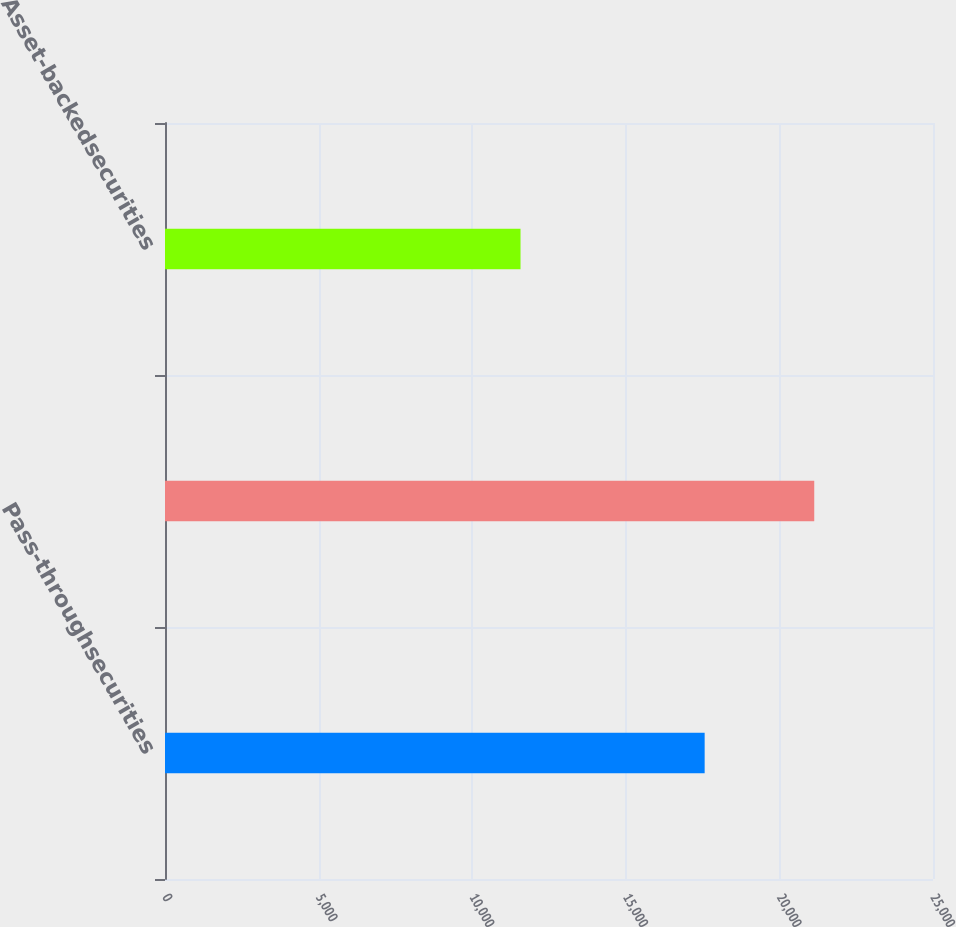Convert chart to OTSL. <chart><loc_0><loc_0><loc_500><loc_500><bar_chart><fcel>Pass-throughsecurities<fcel>Unnamed: 1<fcel>Asset-backedsecurities<nl><fcel>17567<fcel>21134.3<fcel>11573<nl></chart> 